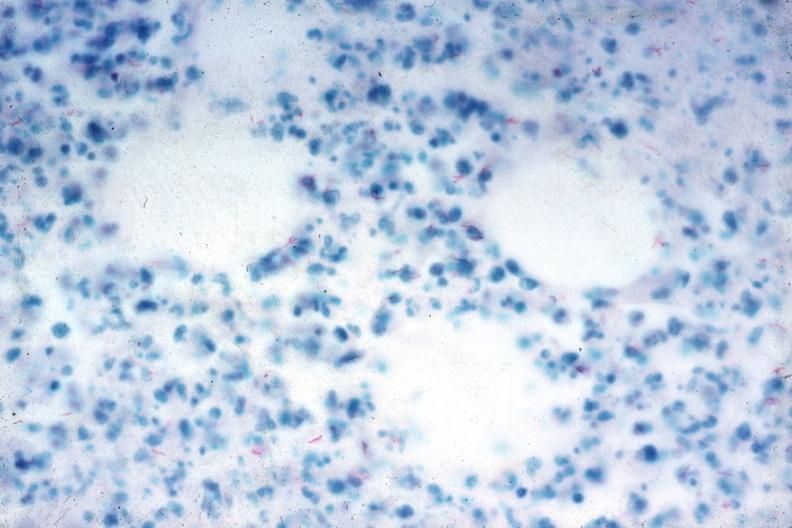s peritoneum present?
Answer the question using a single word or phrase. Yes 